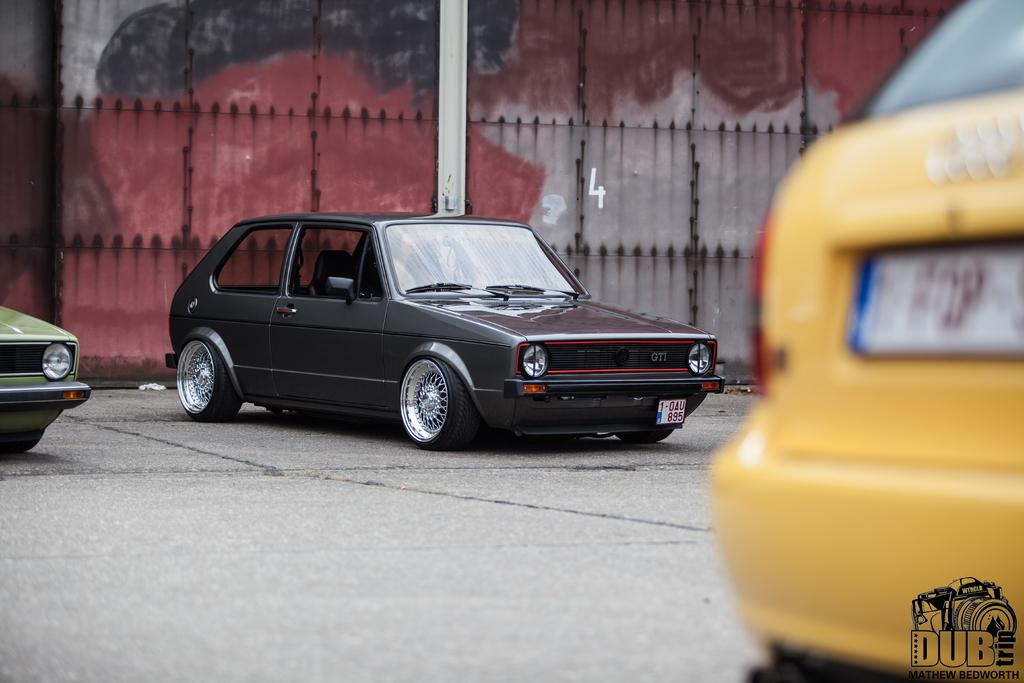Provide a one-sentence caption for the provided image. Dub trip is on the back bumper of a yellow vehicle. 